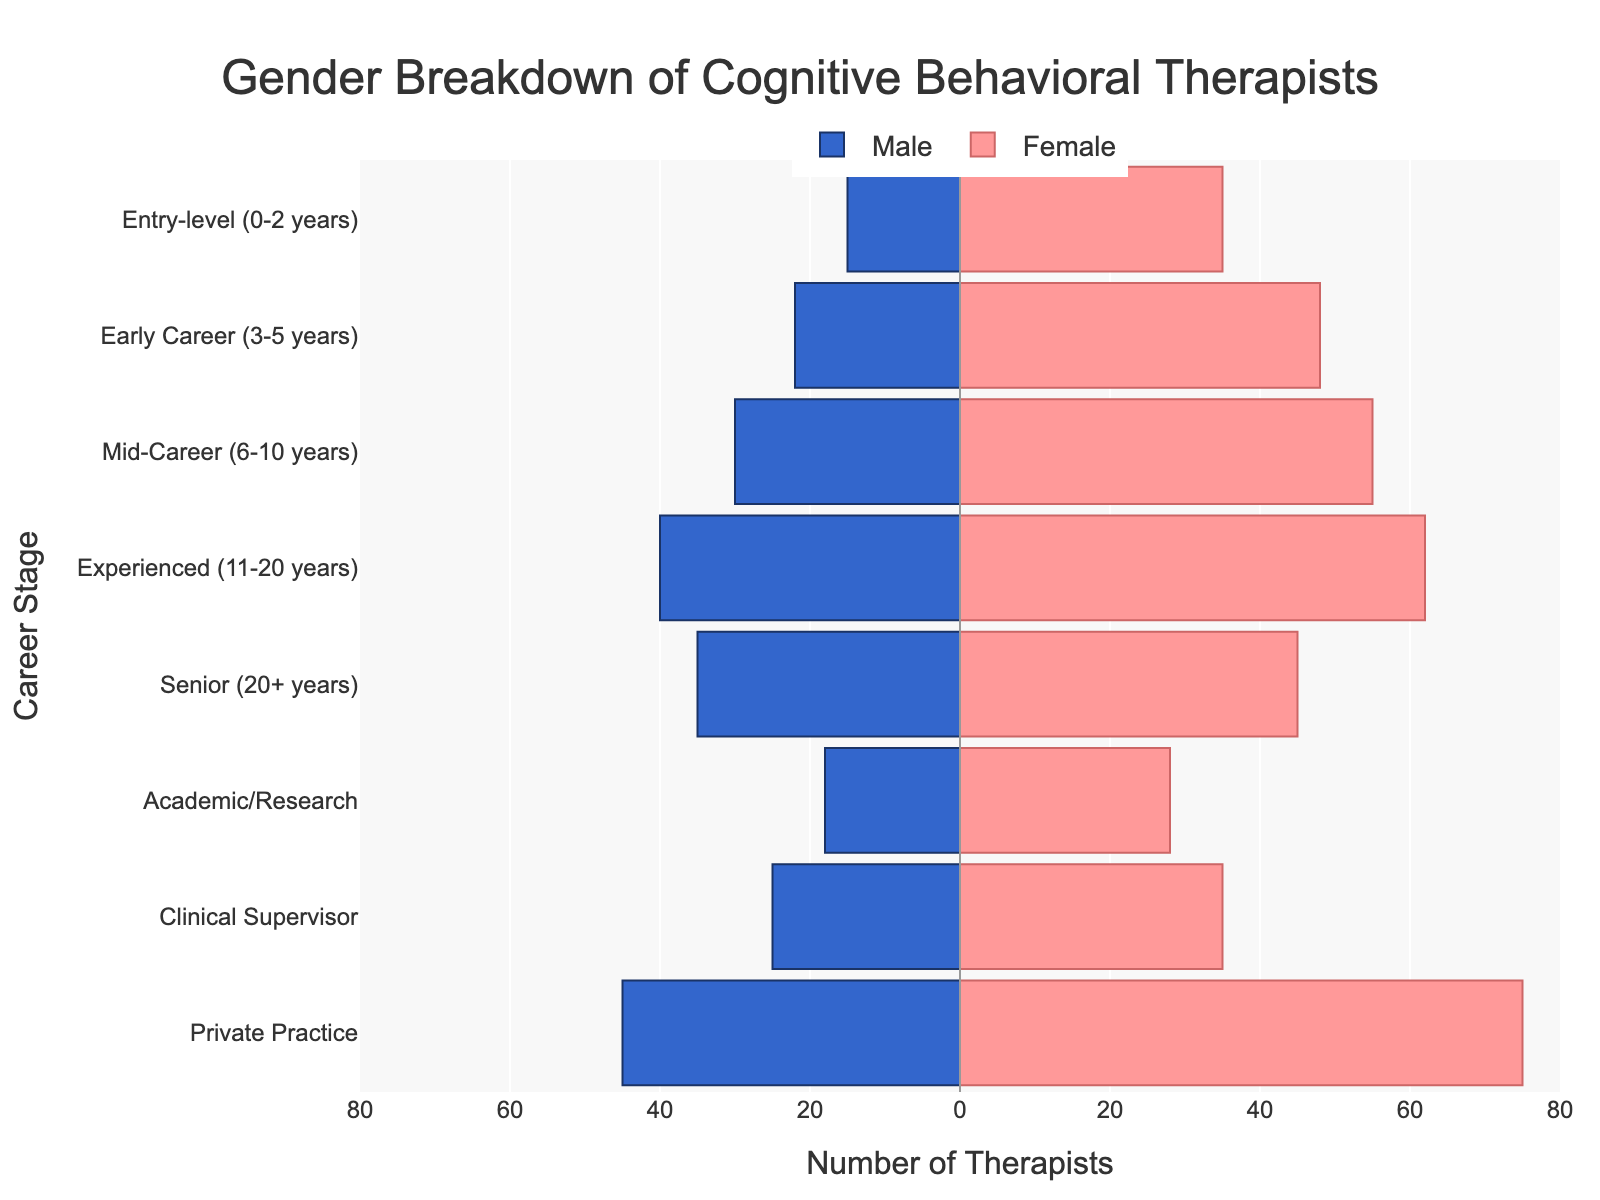What is the title of the figure? The title is at the top center of the figure and reads: 'Gender Breakdown of Cognitive Behavioral Therapists'.
Answer: Gender Breakdown of Cognitive Behavioral Therapists Which career stage has the highest number of male therapists? Looking at the left side of the pyramid, the highest bar corresponds to 'Private Practice', indicating it has the most male therapists.
Answer: Private Practice What is the difference in the number of female therapists between the 'Entry-level' and 'Senior' career stages? For 'Entry-level', there are 35 female therapists, and for 'Senior', there are 45. The difference is computed as 45 - 35 = 10.
Answer: 10 Which gender is more represented in the 'Early Career' stage? Comparing the bars for 'Early Career', the female bar is longer than the male bar, indicating more females.
Answer: Female How many therapists are at the 'Academic/Research' stage in total? Add the number of male (18) and female therapists (28) together: 18 + 28 = 46.
Answer: 46 What is the total number of male therapists in 'Mid-Career' and 'Experienced' combined? Sum the male counts for 'Mid-Career' (30) and 'Experienced' (40): 30 + 40 = 70.
Answer: 70 How does the number of female therapists change from 'Entry-level' to 'Experienced'? The number of female therapists increases from 35 at 'Entry-level' to 62 at 'Experienced'. This shows an increase of 62 - 35 = 27.
Answer: Increases by 27 In which career stage is the gender ratio closest to equal? By observing the lengths of the male and female bars, 'Senior' stage has the closest lengths with males at 35 and females at 45, showing the smallest difference.
Answer: Senior What is the range of the x-axis values? The x-axis ranges from -80 to 80, representing the number of therapists, with negative values for males and positive for females.
Answer: -80 to 80 Which career stage has the smallest number of therapists in total? Reviewing all bars from both sides, 'Academic/Research' has the smallest combined total with 18 males and 28 females, totaling 46 therapists.
Answer: Academic/Research 